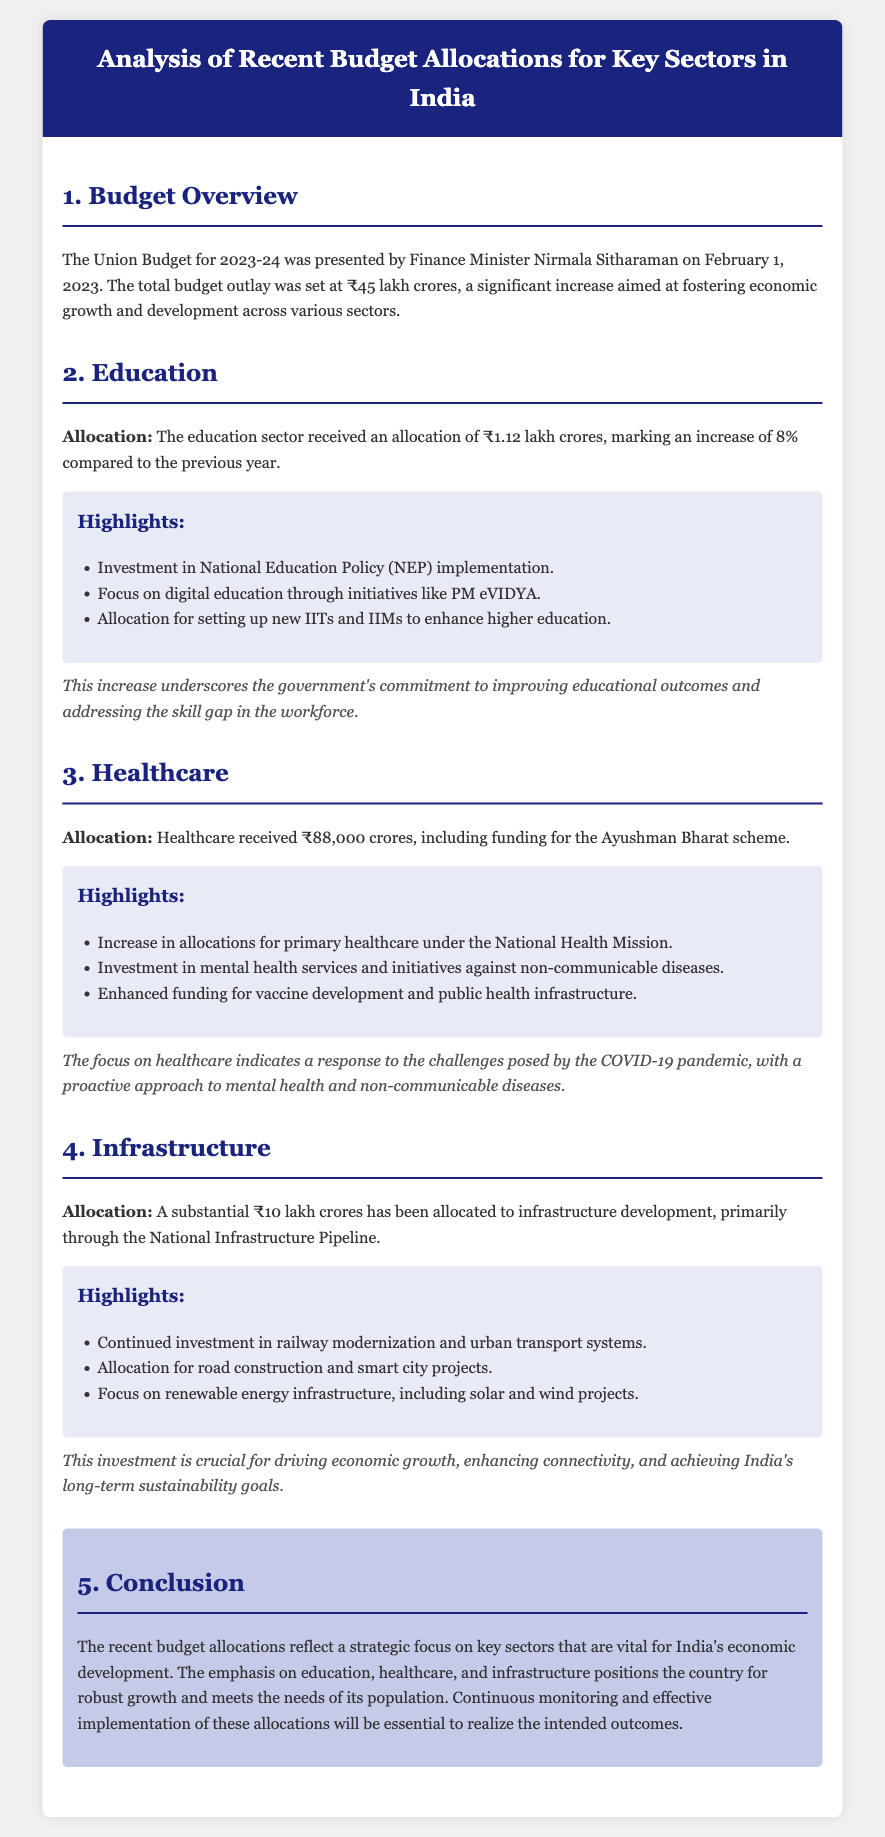What is the total budget outlay for 2023-24? The total budget outlay for 2023-24 was set at ₹45 lakh crores.
Answer: ₹45 lakh crores How much was allocated to the education sector? The education sector received an allocation of ₹1.12 lakh crores.
Answer: ₹1.12 lakh crores What percentage increase did the education sector see compared to the previous year? The education sector saw an increase of 8% compared to the previous year.
Answer: 8% What is the allocation for healthcare? Healthcare received ₹88,000 crores.
Answer: ₹88,000 crores What major healthcare initiative is included in the budget? Funding for the Ayushman Bharat scheme is included in the healthcare allocation.
Answer: Ayushman Bharat How much has been allocated to infrastructure development? A substantial ₹10 lakh crores has been allocated to infrastructure development.
Answer: ₹10 lakh crores What are the highlights of the education sector allocation? The highlights include investment in National Education Policy implementation and focus on digital education.
Answer: NEP implementation and digital education Why is the healthcare focus important according to the document? It indicates a response to challenges posed by the COVID-19 pandemic.
Answer: COVID-19 pandemic What overarching theme is emphasized in the conclusion of the document? The conclusion emphasizes strategic focus on key sectors vital for economic development.
Answer: Strategic focus on key sectors 